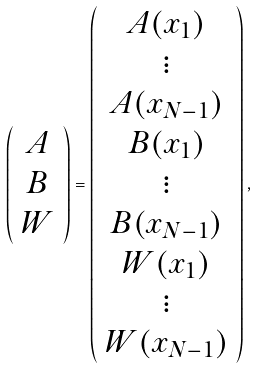<formula> <loc_0><loc_0><loc_500><loc_500>\left ( \begin{array} { c } A \\ B \\ W \end{array} \right ) = \left ( \begin{array} { c } A ( x _ { 1 } ) \\ \vdots \\ A ( x _ { N - 1 } ) \\ B ( x _ { 1 } ) \\ \vdots \\ B ( x _ { N - 1 } ) \\ W ( x _ { 1 } ) \\ \vdots \\ W ( x _ { N - 1 } ) \end{array} \right ) ,</formula> 